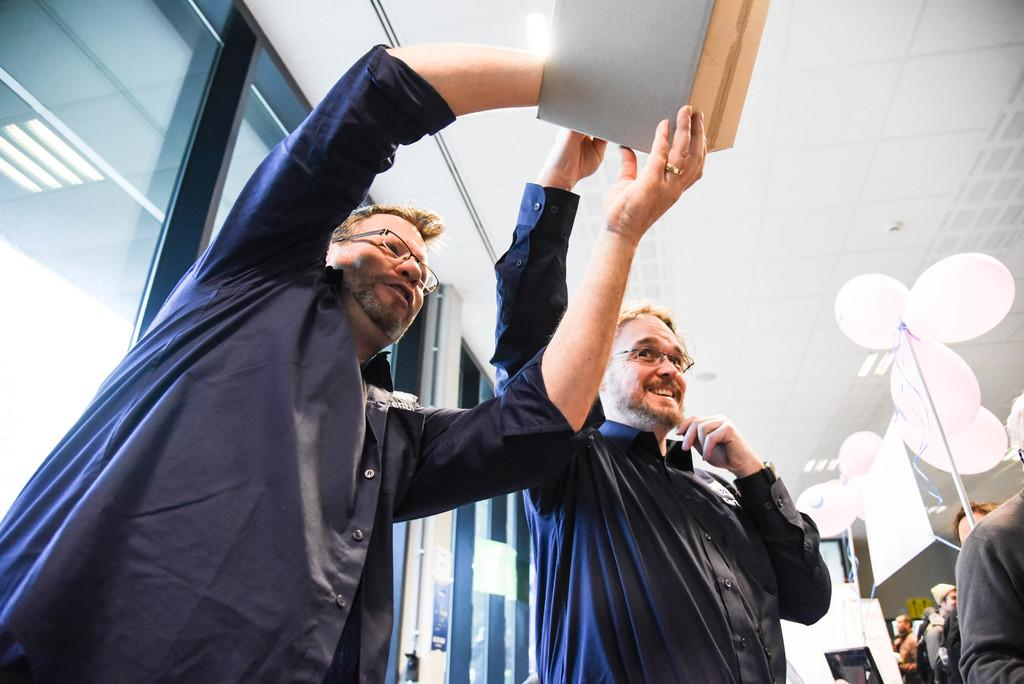What are the two persons in the image doing? The two persons are standing and holding an object. Can you describe the lighting in the image? Yes, there are lights in the image. What decorative items can be seen in the image? There are balloons in the image. How many people are present in the image? There is a group of people in the image. What architectural feature is visible in the image? There are glass doors in the image. What type of bucket is being used to collect hair in the image? There is no bucket or hair present in the image. 